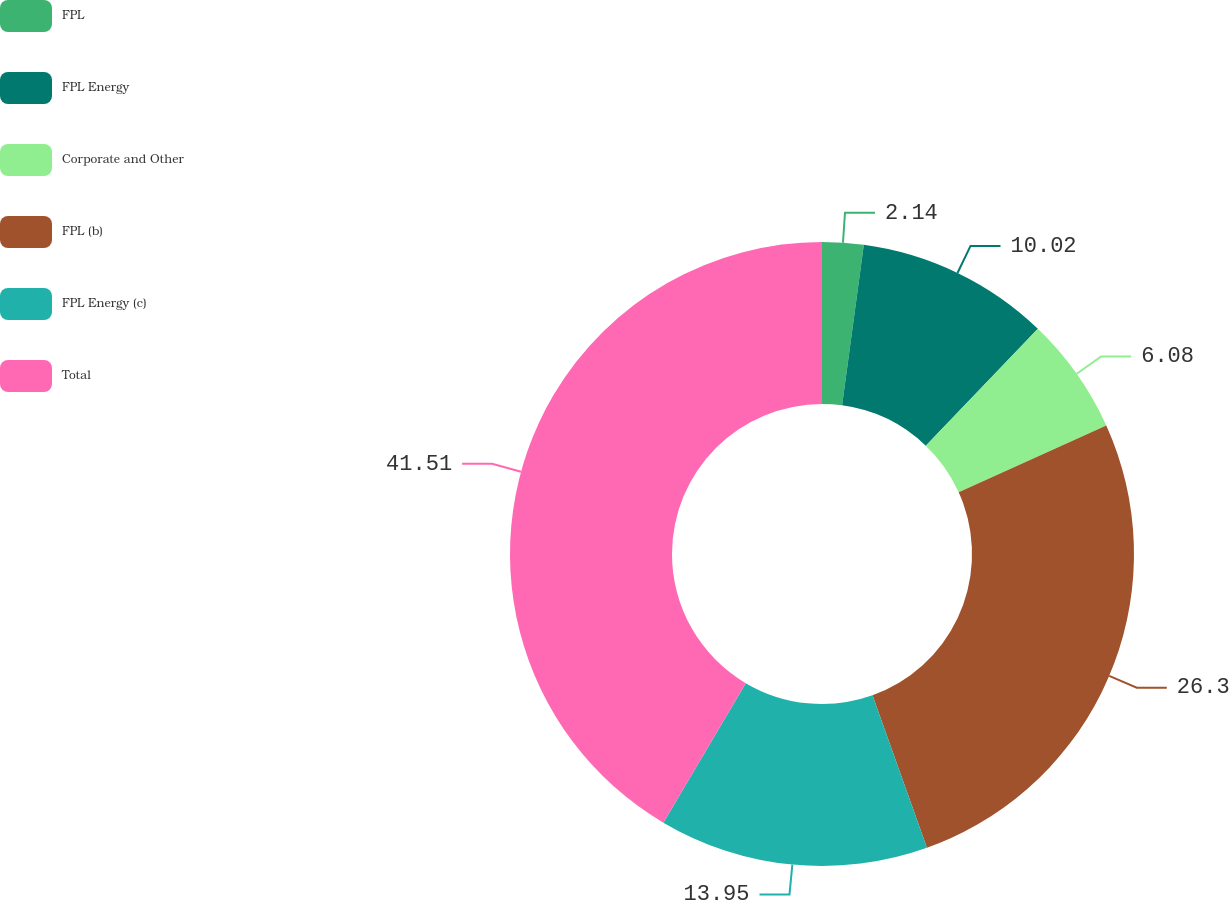Convert chart to OTSL. <chart><loc_0><loc_0><loc_500><loc_500><pie_chart><fcel>FPL<fcel>FPL Energy<fcel>Corporate and Other<fcel>FPL (b)<fcel>FPL Energy (c)<fcel>Total<nl><fcel>2.14%<fcel>10.02%<fcel>6.08%<fcel>26.3%<fcel>13.95%<fcel>41.51%<nl></chart> 